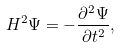<formula> <loc_0><loc_0><loc_500><loc_500>H ^ { 2 } \Psi = - \frac { \partial ^ { 2 } \Psi } { \partial t ^ { 2 } } ,</formula> 